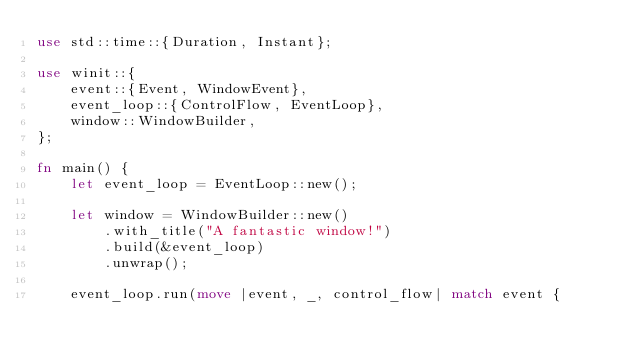Convert code to text. <code><loc_0><loc_0><loc_500><loc_500><_Rust_>use std::time::{Duration, Instant};

use winit::{
    event::{Event, WindowEvent},
    event_loop::{ControlFlow, EventLoop},
    window::WindowBuilder,
};

fn main() {
    let event_loop = EventLoop::new();

    let window = WindowBuilder::new()
        .with_title("A fantastic window!")
        .build(&event_loop)
        .unwrap();

    event_loop.run(move |event, _, control_flow| match event {</code> 